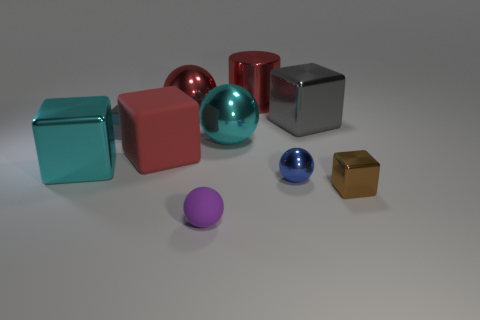There is another matte thing that is the same shape as the blue thing; what is its size?
Provide a short and direct response. Small. How many large things are cyan metallic balls or gray metal cubes?
Your response must be concise. 2. Do the large cyan object that is to the left of the small purple thing and the sphere in front of the blue ball have the same material?
Make the answer very short. No. What material is the small ball that is left of the cyan metal sphere?
Give a very brief answer. Rubber. How many matte objects are brown things or small purple spheres?
Provide a succinct answer. 1. The big shiny cube that is on the right side of the tiny metal object behind the large cyan block is what color?
Provide a succinct answer. Gray. Do the cyan block and the tiny thing that is in front of the tiny brown thing have the same material?
Your answer should be compact. No. What color is the large metallic sphere behind the tiny block that is left of the tiny shiny block that is in front of the cyan metal cube?
Make the answer very short. Red. Are there more gray cubes than spheres?
Provide a short and direct response. No. How many blocks are both to the right of the large shiny cylinder and left of the tiny gray object?
Your response must be concise. 0. 